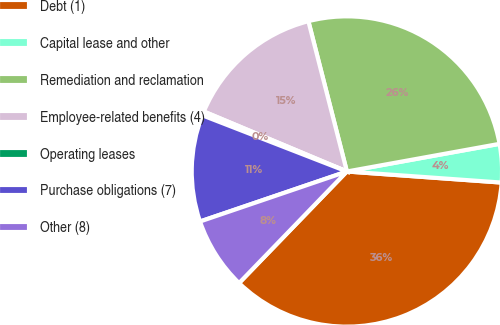Convert chart to OTSL. <chart><loc_0><loc_0><loc_500><loc_500><pie_chart><fcel>Debt (1)<fcel>Capital lease and other<fcel>Remediation and reclamation<fcel>Employee-related benefits (4)<fcel>Operating leases<fcel>Purchase obligations (7)<fcel>Other (8)<nl><fcel>36.09%<fcel>3.99%<fcel>26.14%<fcel>14.69%<fcel>0.42%<fcel>11.12%<fcel>7.55%<nl></chart> 